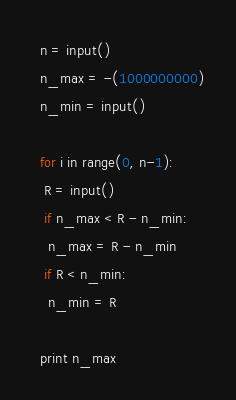Convert code to text. <code><loc_0><loc_0><loc_500><loc_500><_Python_>  n = input()
  n_max = -(1000000000)
  n_min = input()

  for i in range(0, n-1):
   R = input()
   if n_max < R - n_min:
    n_max = R - n_min
   if R < n_min:
    n_min = R

  print n_max</code> 